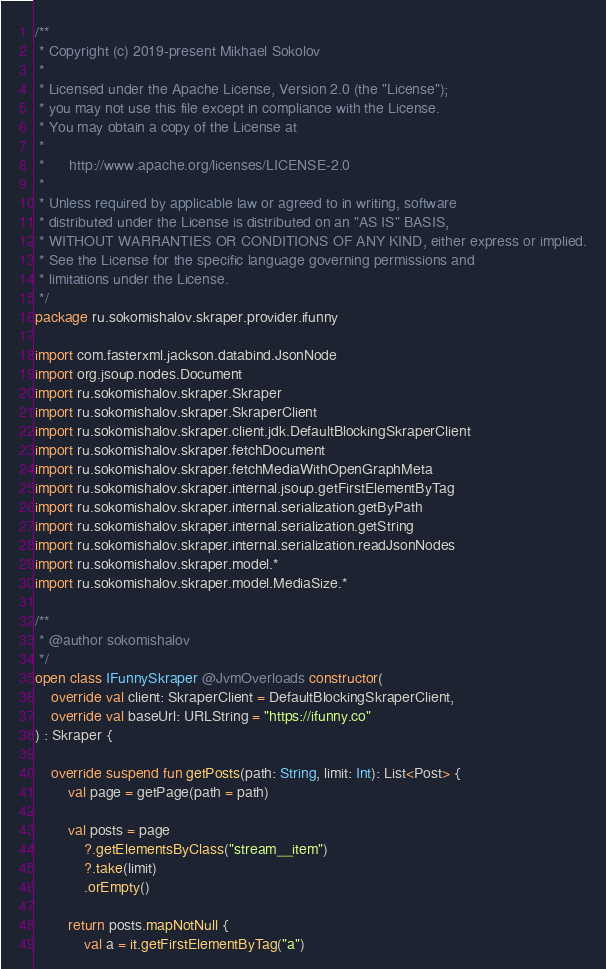Convert code to text. <code><loc_0><loc_0><loc_500><loc_500><_Kotlin_>/**
 * Copyright (c) 2019-present Mikhael Sokolov
 *
 * Licensed under the Apache License, Version 2.0 (the "License");
 * you may not use this file except in compliance with the License.
 * You may obtain a copy of the License at
 *
 *      http://www.apache.org/licenses/LICENSE-2.0
 *
 * Unless required by applicable law or agreed to in writing, software
 * distributed under the License is distributed on an "AS IS" BASIS,
 * WITHOUT WARRANTIES OR CONDITIONS OF ANY KIND, either express or implied.
 * See the License for the specific language governing permissions and
 * limitations under the License.
 */
package ru.sokomishalov.skraper.provider.ifunny

import com.fasterxml.jackson.databind.JsonNode
import org.jsoup.nodes.Document
import ru.sokomishalov.skraper.Skraper
import ru.sokomishalov.skraper.SkraperClient
import ru.sokomishalov.skraper.client.jdk.DefaultBlockingSkraperClient
import ru.sokomishalov.skraper.fetchDocument
import ru.sokomishalov.skraper.fetchMediaWithOpenGraphMeta
import ru.sokomishalov.skraper.internal.jsoup.getFirstElementByTag
import ru.sokomishalov.skraper.internal.serialization.getByPath
import ru.sokomishalov.skraper.internal.serialization.getString
import ru.sokomishalov.skraper.internal.serialization.readJsonNodes
import ru.sokomishalov.skraper.model.*
import ru.sokomishalov.skraper.model.MediaSize.*

/**
 * @author sokomishalov
 */
open class IFunnySkraper @JvmOverloads constructor(
    override val client: SkraperClient = DefaultBlockingSkraperClient,
    override val baseUrl: URLString = "https://ifunny.co"
) : Skraper {

    override suspend fun getPosts(path: String, limit: Int): List<Post> {
        val page = getPage(path = path)

        val posts = page
            ?.getElementsByClass("stream__item")
            ?.take(limit)
            .orEmpty()

        return posts.mapNotNull {
            val a = it.getFirstElementByTag("a")
</code> 